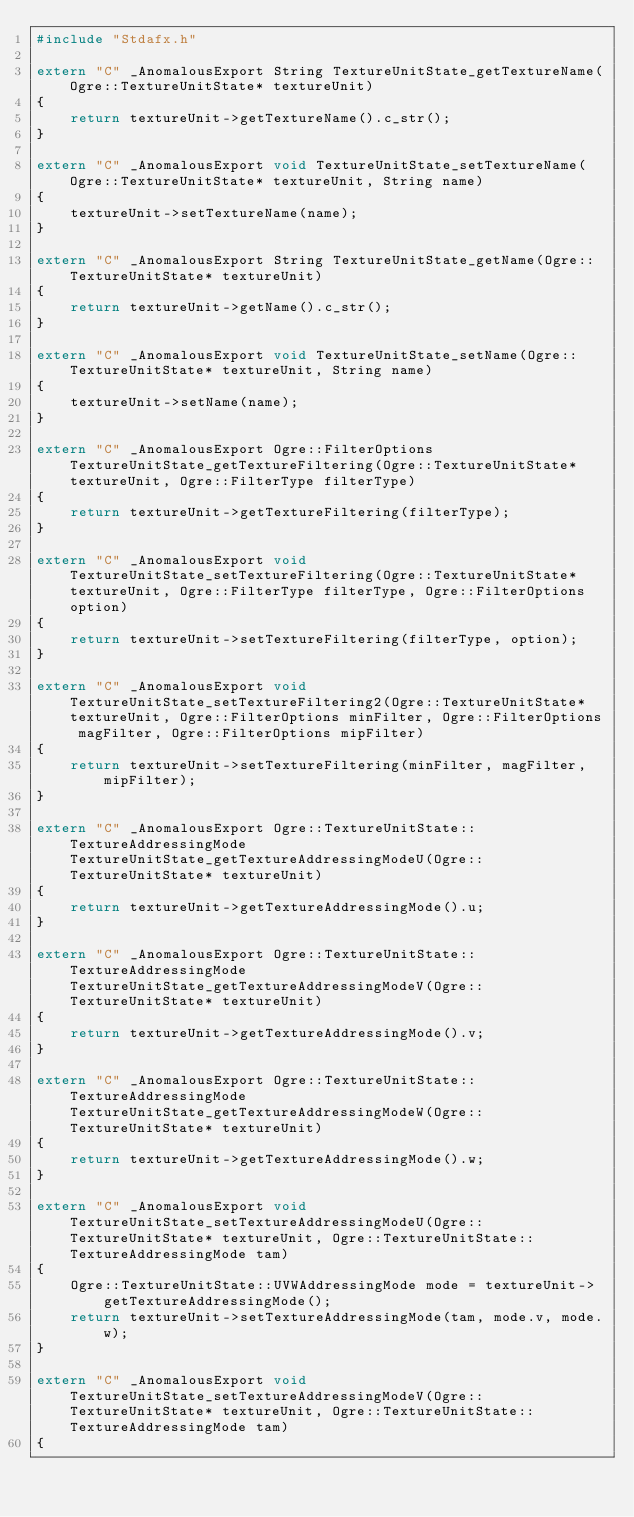<code> <loc_0><loc_0><loc_500><loc_500><_C++_>#include "Stdafx.h"

extern "C" _AnomalousExport String TextureUnitState_getTextureName(Ogre::TextureUnitState* textureUnit)
{
	return textureUnit->getTextureName().c_str();
}

extern "C" _AnomalousExport void TextureUnitState_setTextureName(Ogre::TextureUnitState* textureUnit, String name)
{
	textureUnit->setTextureName(name);
}

extern "C" _AnomalousExport String TextureUnitState_getName(Ogre::TextureUnitState* textureUnit)
{
	return textureUnit->getName().c_str();
}

extern "C" _AnomalousExport void TextureUnitState_setName(Ogre::TextureUnitState* textureUnit, String name)
{
	textureUnit->setName(name);
}

extern "C" _AnomalousExport Ogre::FilterOptions TextureUnitState_getTextureFiltering(Ogre::TextureUnitState* textureUnit, Ogre::FilterType filterType)
{
	return textureUnit->getTextureFiltering(filterType);
}

extern "C" _AnomalousExport void TextureUnitState_setTextureFiltering(Ogre::TextureUnitState* textureUnit, Ogre::FilterType filterType, Ogre::FilterOptions option)
{
	return textureUnit->setTextureFiltering(filterType, option);
}

extern "C" _AnomalousExport void TextureUnitState_setTextureFiltering2(Ogre::TextureUnitState* textureUnit, Ogre::FilterOptions minFilter, Ogre::FilterOptions magFilter, Ogre::FilterOptions mipFilter)
{
	return textureUnit->setTextureFiltering(minFilter, magFilter, mipFilter);
}

extern "C" _AnomalousExport Ogre::TextureUnitState::TextureAddressingMode TextureUnitState_getTextureAddressingModeU(Ogre::TextureUnitState* textureUnit)
{
	return textureUnit->getTextureAddressingMode().u;
}

extern "C" _AnomalousExport Ogre::TextureUnitState::TextureAddressingMode TextureUnitState_getTextureAddressingModeV(Ogre::TextureUnitState* textureUnit)
{
	return textureUnit->getTextureAddressingMode().v;
}

extern "C" _AnomalousExport Ogre::TextureUnitState::TextureAddressingMode TextureUnitState_getTextureAddressingModeW(Ogre::TextureUnitState* textureUnit)
{
	return textureUnit->getTextureAddressingMode().w;
}

extern "C" _AnomalousExport void TextureUnitState_setTextureAddressingModeU(Ogre::TextureUnitState* textureUnit, Ogre::TextureUnitState::TextureAddressingMode tam)
{
	Ogre::TextureUnitState::UVWAddressingMode mode = textureUnit->getTextureAddressingMode();
	return textureUnit->setTextureAddressingMode(tam, mode.v, mode.w);
}

extern "C" _AnomalousExport void TextureUnitState_setTextureAddressingModeV(Ogre::TextureUnitState* textureUnit, Ogre::TextureUnitState::TextureAddressingMode tam)
{</code> 